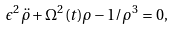<formula> <loc_0><loc_0><loc_500><loc_500>\epsilon ^ { 2 } \ddot { \rho } + \Omega ^ { 2 } ( t ) \rho - 1 / \rho ^ { 3 } = 0 ,</formula> 